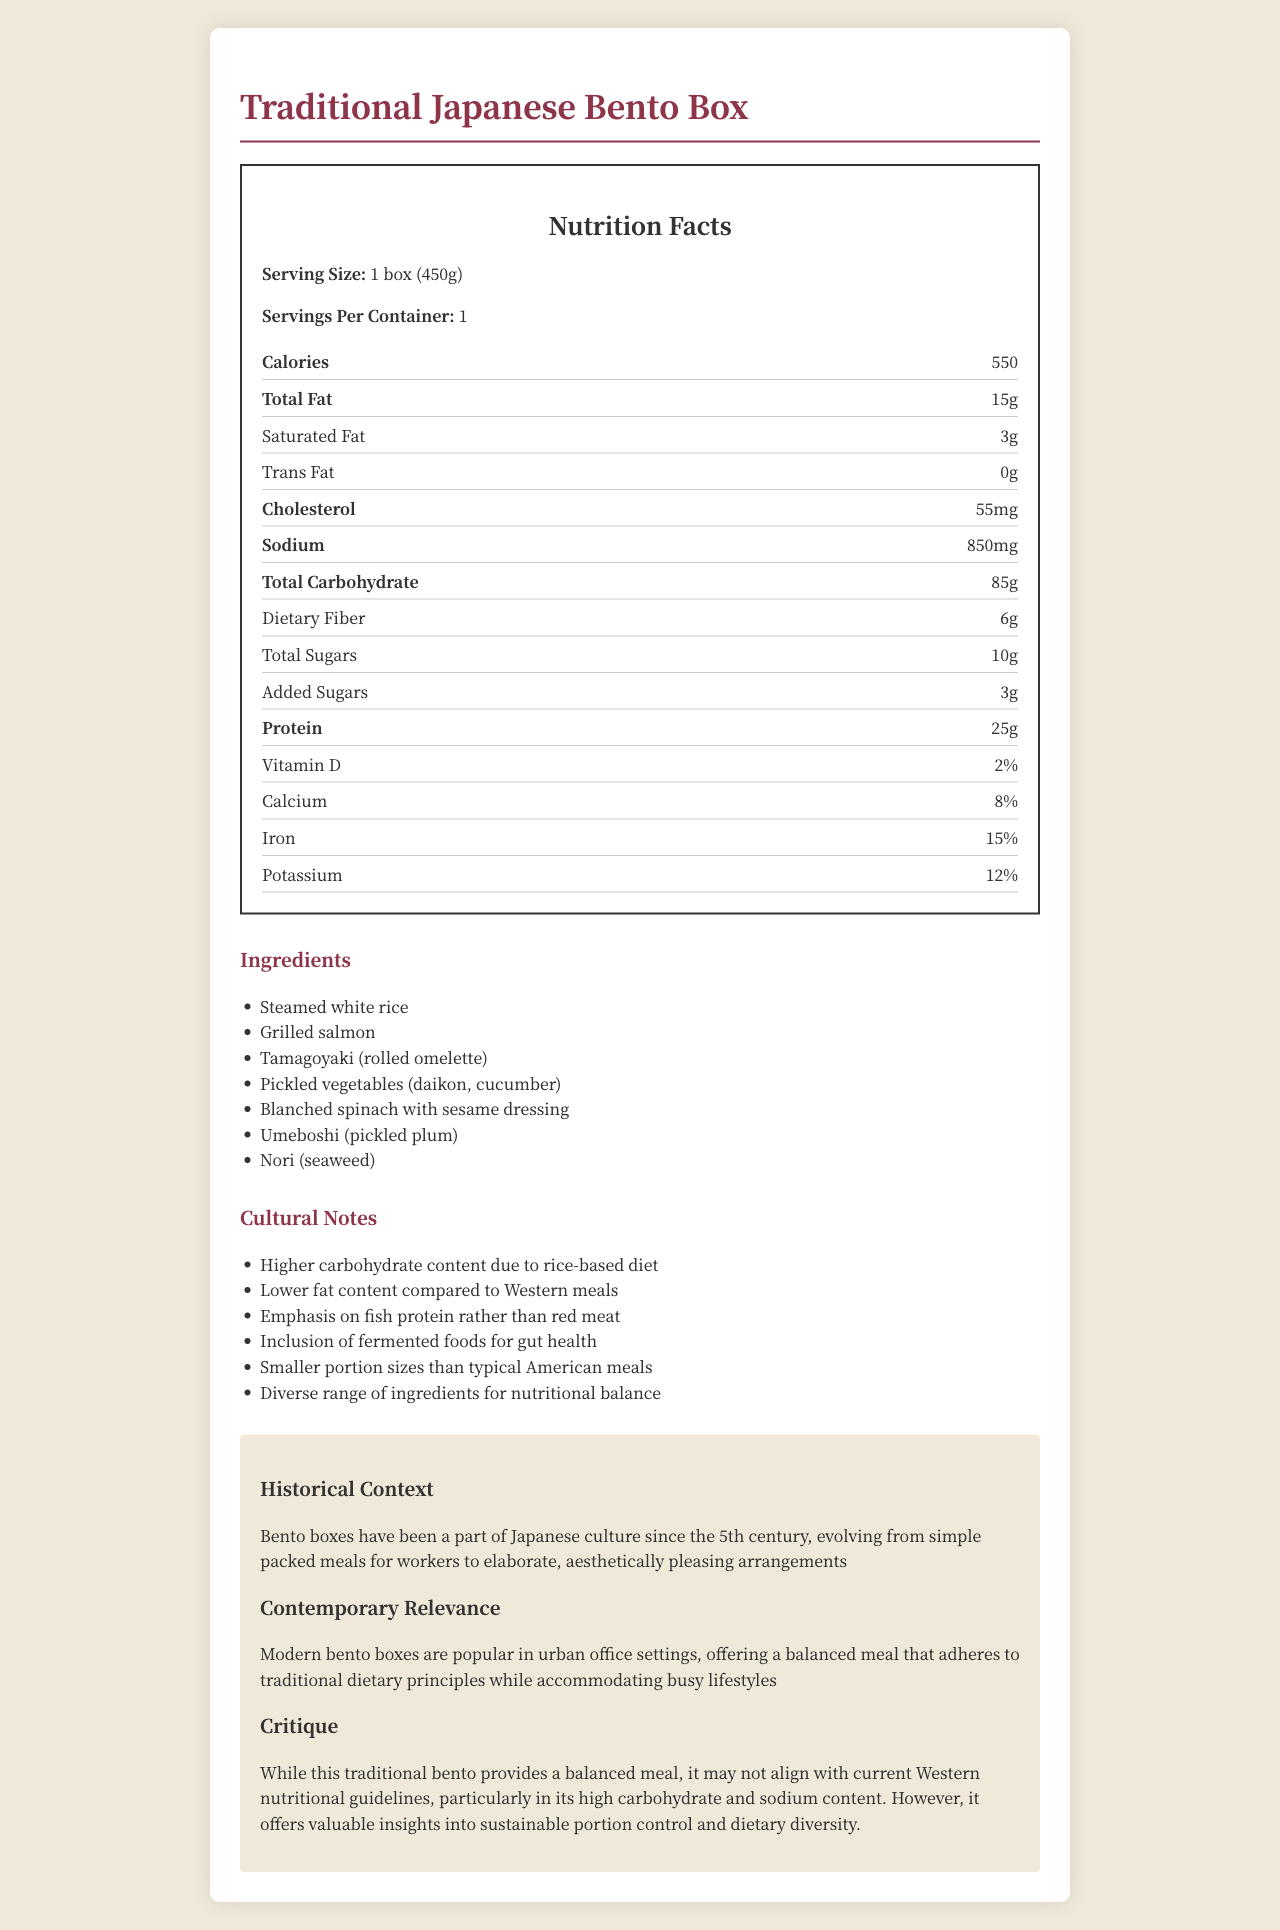What is the serving size of the Traditional Japanese Bento Box? The serving size is listed at the top of the nutrition label as "Serving Size: 1 box (450g)".
Answer: 1 box (450g) What is the total number of calories in one serving? The document states that there are 550 calories in one serving.
Answer: 550 How much protein does the bento box contain? The nutrition label indicates that the bento box contains 25 grams of protein.
Answer: 25g What are the main sources of protein in the bento box? The ingredients list mentions grilled salmon and tamagoyaki, both of which are high in protein.
Answer: Grilled salmon, Tamagoyaki (rolled omelette) What is the total carbohydrate content of the bento box? The nutrition label specifies a total carbohydrate content of 85 grams.
Answer: 85g How much saturated fat is there in the bento box? The nutritional information shows that the bento box contains 3 grams of saturated fat.
Answer: 3g Which one of the following is a key cultural note mentioned? A. High-fat content B. Emphasis on fish protein C. High added sugars The cultural notes section specifically mentions an emphasis on fish protein rather than red meats.
Answer: B What is the sodium content in the bento box? A. 750mg B. 850mg C. 900mg The document states that the sodium content is 850 mg.
Answer: B Is this bento box high in carbohydrate due to its rice-based diet? One of the cultural notes explicitly points out the higher carbohydrate content due to the rice-based diet.
Answer: Yes Was the bento box first introduced in the 10th century? The historical context states that bento boxes have been part of Japanese culture since the 5th century.
Answer: No Summarize the main points of the document. The document covers detailed nutritional information, cultural and historical significance, practical relevance in modern settings, and a critique of a traditional Japanese bento box.
Answer: The document provides nutritional information for a Traditional Japanese Bento Box, emphasizing its balanced mix of ingredients, high carbohydrate content primarily from rice, lower fat content, and a focus on fish protein. Cultural and historical notes highlight the significance of bento boxes in Japanese culture and their relevance in modern urban settings. There is a critique mentioning both the alignment with traditional dietary principles and deviations from Western nutritional guidelines. How does this bento box compare to typical Western meals in terms of fat content? The cultural notes mention that this bento box has a lower fat content compared to Western meals.
Answer: Lower What percentage of the daily recommended intake for Vitamin D does this bento box provide? The nutrition label lists Vitamin D at 2%.
Answer: 2% What is the added sugar content in the bento box? The nutrition facts specify that there are 3 grams of added sugars.
Answer: 3g Why might someone choose this bento box over a typical American meal? The document's cultural and nutritional notes highlight these benefits, including portion control, dietary diversity, and emphasis on fish protein.
Answer: For balanced nutrition and portion control, emphasis on fish protein, low fat, and dietary diversity. How much calcium does the bento box provide relative to the daily recommended intake? The nutrition label displays that the bento box provides 8% of the daily recommended intake for calcium.
Answer: 8% 